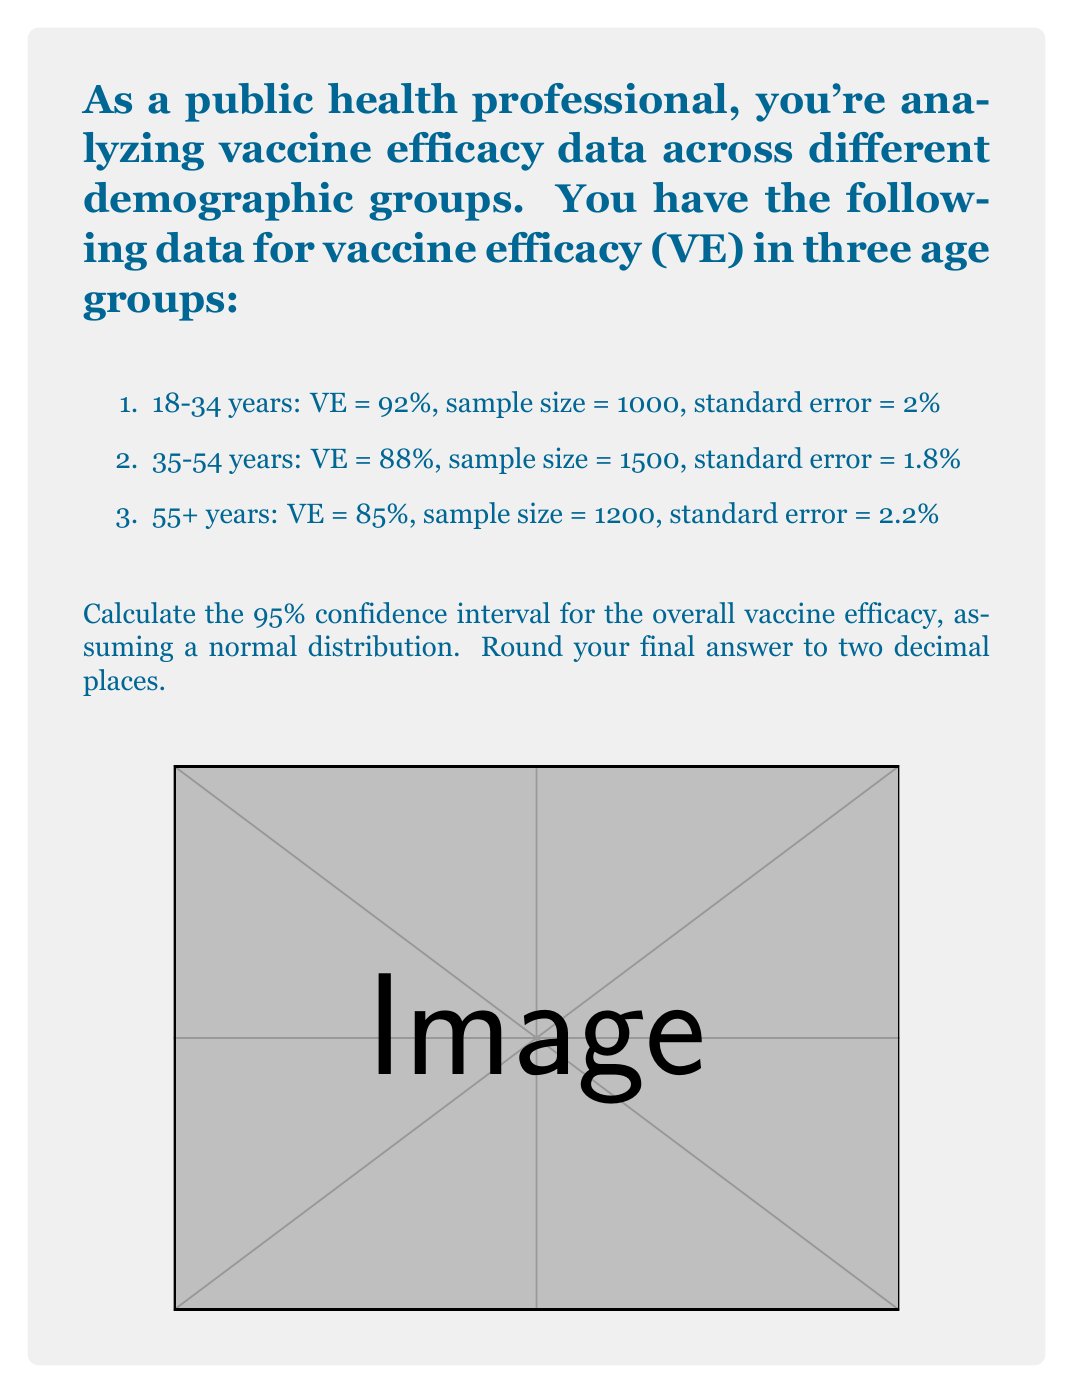Could you help me with this problem? To calculate the overall vaccine efficacy and its confidence interval, we'll follow these steps:

1) Calculate the weighted average of VE:
   Let $w_i = \frac{1}{SE_i^2}$ be the weight for each group.
   
   $w_1 = \frac{1}{2^2} = 0.25$
   $w_2 = \frac{1}{1.8^2} = 0.3086$
   $w_3 = \frac{1}{2.2^2} = 0.2066$

   Weighted average VE = $\frac{\sum w_i VE_i}{\sum w_i}$

   $= \frac{0.25 * 92 + 0.3086 * 88 + 0.2066 * 85}{0.25 + 0.3086 + 0.2066}$
   $= \frac{71.761}{0.7652} = 88.42\%$

2) Calculate the standard error of the weighted average:
   $SE_{weighted} = \sqrt{\frac{1}{\sum w_i}}$
   $= \sqrt{\frac{1}{0.7652}} = 1.14\%$

3) For a 95% confidence interval, use z-score of 1.96:
   CI = VE ± (1.96 * SE)
   
   Lower bound = 88.42 - (1.96 * 1.14) = 86.19%
   Upper bound = 88.42 + (1.96 * 1.14) = 90.65%

Therefore, the 95% confidence interval for the overall vaccine efficacy is (86.19%, 90.65%).
Answer: (86.19%, 90.65%) 